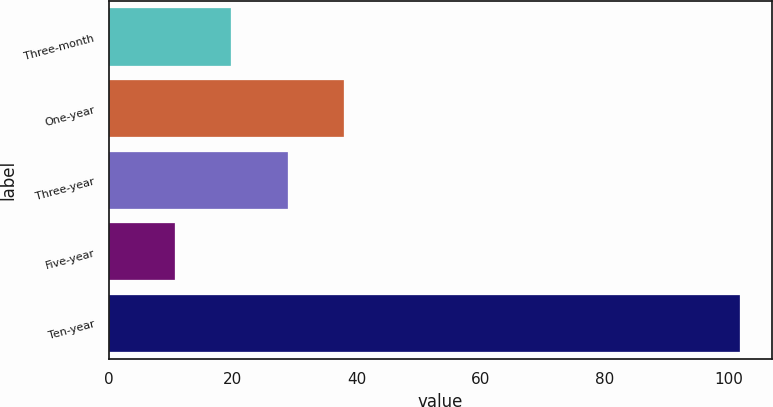Convert chart to OTSL. <chart><loc_0><loc_0><loc_500><loc_500><bar_chart><fcel>Three-month<fcel>One-year<fcel>Three-year<fcel>Five-year<fcel>Ten-year<nl><fcel>19.72<fcel>37.96<fcel>28.84<fcel>10.6<fcel>101.8<nl></chart> 